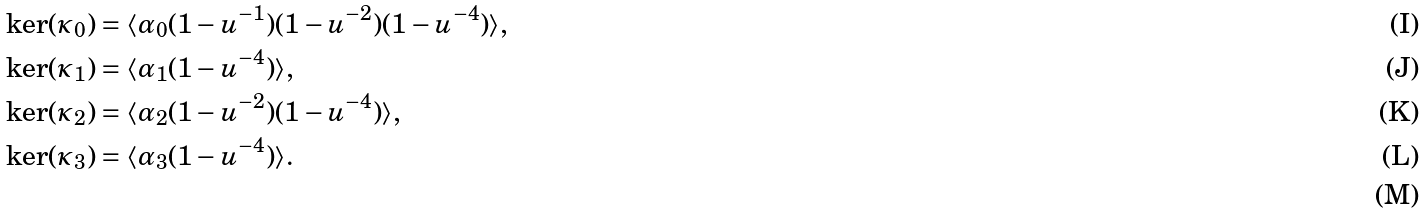<formula> <loc_0><loc_0><loc_500><loc_500>\ker ( \kappa _ { 0 } ) & = \langle \alpha _ { 0 } ( 1 - u ^ { - 1 } ) ( 1 - u ^ { - 2 } ) ( 1 - u ^ { - 4 } ) \rangle , \\ \ker ( \kappa _ { 1 } ) & = \langle \alpha _ { 1 } ( 1 - u ^ { - 4 } ) \rangle , \\ \ker ( \kappa _ { 2 } ) & = \langle \alpha _ { 2 } ( 1 - u ^ { - 2 } ) ( 1 - u ^ { - 4 } ) \rangle , \\ \ker ( \kappa _ { 3 } ) & = \langle \alpha _ { 3 } ( 1 - u ^ { - 4 } ) \rangle . \\</formula> 